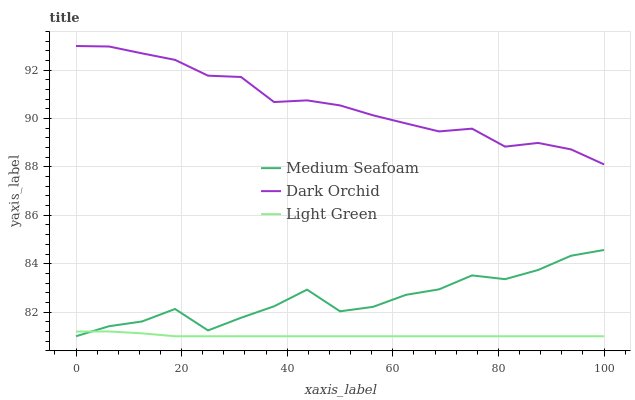Does Light Green have the minimum area under the curve?
Answer yes or no. Yes. Does Dark Orchid have the maximum area under the curve?
Answer yes or no. Yes. Does Medium Seafoam have the minimum area under the curve?
Answer yes or no. No. Does Medium Seafoam have the maximum area under the curve?
Answer yes or no. No. Is Light Green the smoothest?
Answer yes or no. Yes. Is Medium Seafoam the roughest?
Answer yes or no. Yes. Is Dark Orchid the smoothest?
Answer yes or no. No. Is Dark Orchid the roughest?
Answer yes or no. No. Does Light Green have the lowest value?
Answer yes or no. Yes. Does Dark Orchid have the lowest value?
Answer yes or no. No. Does Dark Orchid have the highest value?
Answer yes or no. Yes. Does Medium Seafoam have the highest value?
Answer yes or no. No. Is Light Green less than Dark Orchid?
Answer yes or no. Yes. Is Dark Orchid greater than Medium Seafoam?
Answer yes or no. Yes. Does Medium Seafoam intersect Light Green?
Answer yes or no. Yes. Is Medium Seafoam less than Light Green?
Answer yes or no. No. Is Medium Seafoam greater than Light Green?
Answer yes or no. No. Does Light Green intersect Dark Orchid?
Answer yes or no. No. 